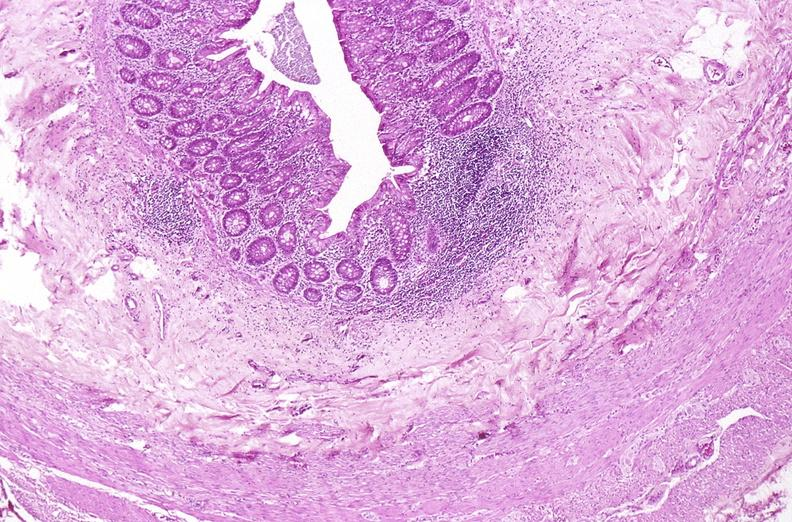where is this from?
Answer the question using a single word or phrase. Gastrointestinal system 